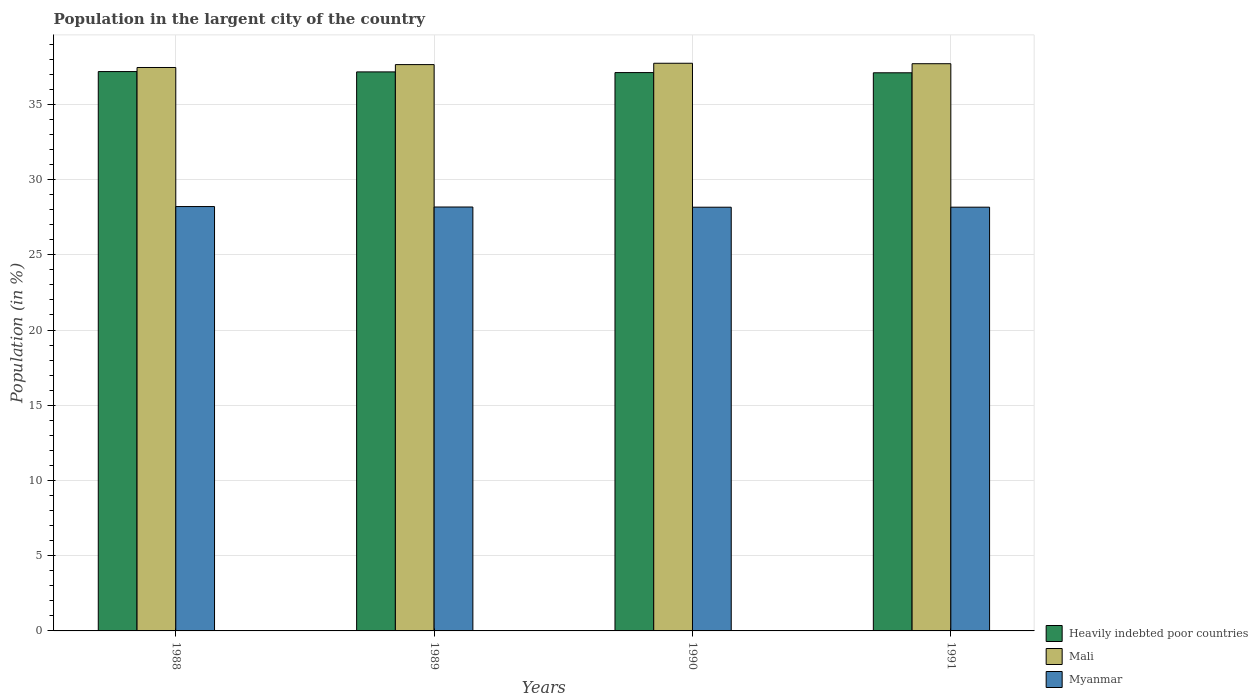Are the number of bars per tick equal to the number of legend labels?
Keep it short and to the point. Yes. How many bars are there on the 4th tick from the left?
Make the answer very short. 3. How many bars are there on the 2nd tick from the right?
Ensure brevity in your answer.  3. In how many cases, is the number of bars for a given year not equal to the number of legend labels?
Offer a very short reply. 0. What is the percentage of population in the largent city in Mali in 1989?
Give a very brief answer. 37.64. Across all years, what is the maximum percentage of population in the largent city in Myanmar?
Your answer should be compact. 28.21. Across all years, what is the minimum percentage of population in the largent city in Mali?
Your response must be concise. 37.45. What is the total percentage of population in the largent city in Myanmar in the graph?
Keep it short and to the point. 112.71. What is the difference between the percentage of population in the largent city in Heavily indebted poor countries in 1988 and that in 1989?
Ensure brevity in your answer.  0.02. What is the difference between the percentage of population in the largent city in Heavily indebted poor countries in 1988 and the percentage of population in the largent city in Mali in 1990?
Give a very brief answer. -0.55. What is the average percentage of population in the largent city in Myanmar per year?
Make the answer very short. 28.18. In the year 1990, what is the difference between the percentage of population in the largent city in Myanmar and percentage of population in the largent city in Heavily indebted poor countries?
Offer a very short reply. -8.95. What is the ratio of the percentage of population in the largent city in Myanmar in 1989 to that in 1991?
Offer a very short reply. 1. Is the percentage of population in the largent city in Heavily indebted poor countries in 1988 less than that in 1989?
Your answer should be compact. No. Is the difference between the percentage of population in the largent city in Myanmar in 1989 and 1990 greater than the difference between the percentage of population in the largent city in Heavily indebted poor countries in 1989 and 1990?
Ensure brevity in your answer.  No. What is the difference between the highest and the second highest percentage of population in the largent city in Mali?
Offer a terse response. 0.03. What is the difference between the highest and the lowest percentage of population in the largent city in Myanmar?
Your answer should be very brief. 0.04. In how many years, is the percentage of population in the largent city in Myanmar greater than the average percentage of population in the largent city in Myanmar taken over all years?
Keep it short and to the point. 1. What does the 3rd bar from the left in 1988 represents?
Offer a very short reply. Myanmar. What does the 2nd bar from the right in 1988 represents?
Your response must be concise. Mali. Are all the bars in the graph horizontal?
Offer a terse response. No. How many years are there in the graph?
Your answer should be very brief. 4. Are the values on the major ticks of Y-axis written in scientific E-notation?
Your answer should be compact. No. Where does the legend appear in the graph?
Provide a short and direct response. Bottom right. How many legend labels are there?
Your answer should be very brief. 3. What is the title of the graph?
Your answer should be very brief. Population in the largent city of the country. Does "Comoros" appear as one of the legend labels in the graph?
Make the answer very short. No. What is the label or title of the X-axis?
Keep it short and to the point. Years. What is the label or title of the Y-axis?
Make the answer very short. Population (in %). What is the Population (in %) in Heavily indebted poor countries in 1988?
Provide a succinct answer. 37.18. What is the Population (in %) in Mali in 1988?
Ensure brevity in your answer.  37.45. What is the Population (in %) in Myanmar in 1988?
Your answer should be compact. 28.21. What is the Population (in %) in Heavily indebted poor countries in 1989?
Your answer should be very brief. 37.16. What is the Population (in %) in Mali in 1989?
Provide a short and direct response. 37.64. What is the Population (in %) of Myanmar in 1989?
Make the answer very short. 28.18. What is the Population (in %) of Heavily indebted poor countries in 1990?
Provide a succinct answer. 37.11. What is the Population (in %) in Mali in 1990?
Ensure brevity in your answer.  37.73. What is the Population (in %) in Myanmar in 1990?
Make the answer very short. 28.16. What is the Population (in %) of Heavily indebted poor countries in 1991?
Provide a succinct answer. 37.1. What is the Population (in %) of Mali in 1991?
Your answer should be very brief. 37.7. What is the Population (in %) of Myanmar in 1991?
Your answer should be compact. 28.16. Across all years, what is the maximum Population (in %) in Heavily indebted poor countries?
Make the answer very short. 37.18. Across all years, what is the maximum Population (in %) in Mali?
Your answer should be very brief. 37.73. Across all years, what is the maximum Population (in %) in Myanmar?
Ensure brevity in your answer.  28.21. Across all years, what is the minimum Population (in %) in Heavily indebted poor countries?
Provide a succinct answer. 37.1. Across all years, what is the minimum Population (in %) in Mali?
Give a very brief answer. 37.45. Across all years, what is the minimum Population (in %) in Myanmar?
Your answer should be compact. 28.16. What is the total Population (in %) in Heavily indebted poor countries in the graph?
Provide a short and direct response. 148.54. What is the total Population (in %) in Mali in the graph?
Ensure brevity in your answer.  150.52. What is the total Population (in %) of Myanmar in the graph?
Keep it short and to the point. 112.71. What is the difference between the Population (in %) of Heavily indebted poor countries in 1988 and that in 1989?
Your answer should be very brief. 0.02. What is the difference between the Population (in %) of Mali in 1988 and that in 1989?
Your response must be concise. -0.19. What is the difference between the Population (in %) of Myanmar in 1988 and that in 1989?
Make the answer very short. 0.03. What is the difference between the Population (in %) of Heavily indebted poor countries in 1988 and that in 1990?
Make the answer very short. 0.07. What is the difference between the Population (in %) in Mali in 1988 and that in 1990?
Ensure brevity in your answer.  -0.28. What is the difference between the Population (in %) in Myanmar in 1988 and that in 1990?
Make the answer very short. 0.04. What is the difference between the Population (in %) in Heavily indebted poor countries in 1988 and that in 1991?
Give a very brief answer. 0.08. What is the difference between the Population (in %) in Mali in 1988 and that in 1991?
Keep it short and to the point. -0.25. What is the difference between the Population (in %) in Myanmar in 1988 and that in 1991?
Your answer should be very brief. 0.04. What is the difference between the Population (in %) in Heavily indebted poor countries in 1989 and that in 1990?
Offer a very short reply. 0.05. What is the difference between the Population (in %) of Mali in 1989 and that in 1990?
Give a very brief answer. -0.09. What is the difference between the Population (in %) of Myanmar in 1989 and that in 1990?
Offer a very short reply. 0.01. What is the difference between the Population (in %) in Heavily indebted poor countries in 1989 and that in 1991?
Keep it short and to the point. 0.06. What is the difference between the Population (in %) in Mali in 1989 and that in 1991?
Give a very brief answer. -0.06. What is the difference between the Population (in %) of Myanmar in 1989 and that in 1991?
Your answer should be compact. 0.01. What is the difference between the Population (in %) in Heavily indebted poor countries in 1990 and that in 1991?
Your answer should be very brief. 0.01. What is the difference between the Population (in %) in Mali in 1990 and that in 1991?
Provide a succinct answer. 0.03. What is the difference between the Population (in %) of Myanmar in 1990 and that in 1991?
Your answer should be very brief. -0. What is the difference between the Population (in %) in Heavily indebted poor countries in 1988 and the Population (in %) in Mali in 1989?
Keep it short and to the point. -0.46. What is the difference between the Population (in %) in Heavily indebted poor countries in 1988 and the Population (in %) in Myanmar in 1989?
Ensure brevity in your answer.  9. What is the difference between the Population (in %) in Mali in 1988 and the Population (in %) in Myanmar in 1989?
Offer a very short reply. 9.27. What is the difference between the Population (in %) in Heavily indebted poor countries in 1988 and the Population (in %) in Mali in 1990?
Offer a very short reply. -0.55. What is the difference between the Population (in %) of Heavily indebted poor countries in 1988 and the Population (in %) of Myanmar in 1990?
Your response must be concise. 9.02. What is the difference between the Population (in %) of Mali in 1988 and the Population (in %) of Myanmar in 1990?
Your response must be concise. 9.29. What is the difference between the Population (in %) in Heavily indebted poor countries in 1988 and the Population (in %) in Mali in 1991?
Ensure brevity in your answer.  -0.52. What is the difference between the Population (in %) of Heavily indebted poor countries in 1988 and the Population (in %) of Myanmar in 1991?
Ensure brevity in your answer.  9.01. What is the difference between the Population (in %) of Mali in 1988 and the Population (in %) of Myanmar in 1991?
Ensure brevity in your answer.  9.28. What is the difference between the Population (in %) of Heavily indebted poor countries in 1989 and the Population (in %) of Mali in 1990?
Provide a short and direct response. -0.57. What is the difference between the Population (in %) in Heavily indebted poor countries in 1989 and the Population (in %) in Myanmar in 1990?
Offer a very short reply. 8.99. What is the difference between the Population (in %) of Mali in 1989 and the Population (in %) of Myanmar in 1990?
Provide a short and direct response. 9.48. What is the difference between the Population (in %) of Heavily indebted poor countries in 1989 and the Population (in %) of Mali in 1991?
Provide a succinct answer. -0.54. What is the difference between the Population (in %) in Heavily indebted poor countries in 1989 and the Population (in %) in Myanmar in 1991?
Your answer should be very brief. 8.99. What is the difference between the Population (in %) of Mali in 1989 and the Population (in %) of Myanmar in 1991?
Give a very brief answer. 9.48. What is the difference between the Population (in %) in Heavily indebted poor countries in 1990 and the Population (in %) in Mali in 1991?
Ensure brevity in your answer.  -0.59. What is the difference between the Population (in %) of Heavily indebted poor countries in 1990 and the Population (in %) of Myanmar in 1991?
Your response must be concise. 8.95. What is the difference between the Population (in %) of Mali in 1990 and the Population (in %) of Myanmar in 1991?
Your response must be concise. 9.57. What is the average Population (in %) of Heavily indebted poor countries per year?
Your answer should be very brief. 37.14. What is the average Population (in %) of Mali per year?
Keep it short and to the point. 37.63. What is the average Population (in %) in Myanmar per year?
Offer a terse response. 28.18. In the year 1988, what is the difference between the Population (in %) of Heavily indebted poor countries and Population (in %) of Mali?
Your answer should be compact. -0.27. In the year 1988, what is the difference between the Population (in %) in Heavily indebted poor countries and Population (in %) in Myanmar?
Your response must be concise. 8.97. In the year 1988, what is the difference between the Population (in %) in Mali and Population (in %) in Myanmar?
Offer a terse response. 9.24. In the year 1989, what is the difference between the Population (in %) in Heavily indebted poor countries and Population (in %) in Mali?
Make the answer very short. -0.49. In the year 1989, what is the difference between the Population (in %) in Heavily indebted poor countries and Population (in %) in Myanmar?
Provide a succinct answer. 8.98. In the year 1989, what is the difference between the Population (in %) of Mali and Population (in %) of Myanmar?
Provide a short and direct response. 9.47. In the year 1990, what is the difference between the Population (in %) of Heavily indebted poor countries and Population (in %) of Mali?
Offer a very short reply. -0.62. In the year 1990, what is the difference between the Population (in %) in Heavily indebted poor countries and Population (in %) in Myanmar?
Your answer should be compact. 8.95. In the year 1990, what is the difference between the Population (in %) in Mali and Population (in %) in Myanmar?
Provide a succinct answer. 9.57. In the year 1991, what is the difference between the Population (in %) in Heavily indebted poor countries and Population (in %) in Mali?
Provide a short and direct response. -0.6. In the year 1991, what is the difference between the Population (in %) of Heavily indebted poor countries and Population (in %) of Myanmar?
Your answer should be very brief. 8.93. In the year 1991, what is the difference between the Population (in %) in Mali and Population (in %) in Myanmar?
Offer a very short reply. 9.54. What is the ratio of the Population (in %) in Mali in 1988 to that in 1989?
Keep it short and to the point. 0.99. What is the ratio of the Population (in %) of Heavily indebted poor countries in 1988 to that in 1990?
Keep it short and to the point. 1. What is the ratio of the Population (in %) of Myanmar in 1988 to that in 1990?
Make the answer very short. 1. What is the ratio of the Population (in %) in Heavily indebted poor countries in 1988 to that in 1991?
Your answer should be compact. 1. What is the ratio of the Population (in %) in Mali in 1988 to that in 1991?
Offer a very short reply. 0.99. What is the ratio of the Population (in %) in Myanmar in 1988 to that in 1991?
Your answer should be very brief. 1. What is the ratio of the Population (in %) in Heavily indebted poor countries in 1989 to that in 1990?
Your answer should be very brief. 1. What is the ratio of the Population (in %) in Mali in 1989 to that in 1990?
Offer a terse response. 1. What is the ratio of the Population (in %) of Heavily indebted poor countries in 1989 to that in 1991?
Your response must be concise. 1. What is the ratio of the Population (in %) of Myanmar in 1989 to that in 1991?
Offer a very short reply. 1. What is the difference between the highest and the second highest Population (in %) in Heavily indebted poor countries?
Keep it short and to the point. 0.02. What is the difference between the highest and the second highest Population (in %) in Mali?
Your answer should be very brief. 0.03. What is the difference between the highest and the second highest Population (in %) of Myanmar?
Provide a succinct answer. 0.03. What is the difference between the highest and the lowest Population (in %) of Heavily indebted poor countries?
Make the answer very short. 0.08. What is the difference between the highest and the lowest Population (in %) in Mali?
Give a very brief answer. 0.28. What is the difference between the highest and the lowest Population (in %) in Myanmar?
Make the answer very short. 0.04. 